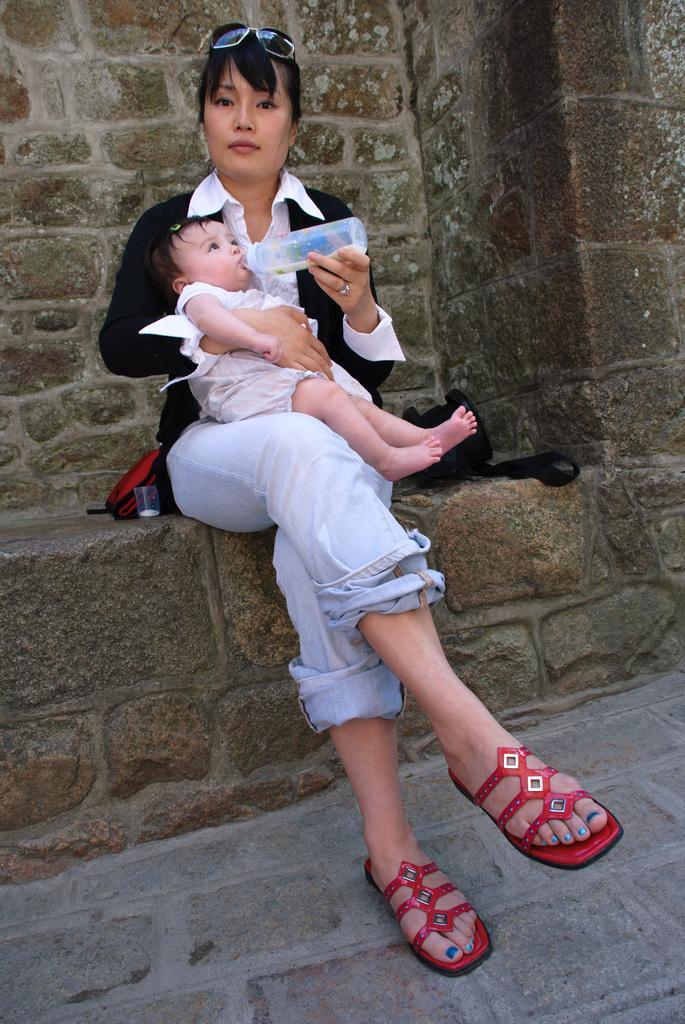Could you give a brief overview of what you see in this image? Here in this picture we can see a woman sitting over a place and she is holding a baby in her hand and feeding the baby with bottle in another hand and we can see goggles on her head and beside her we can see a bag present over there. 